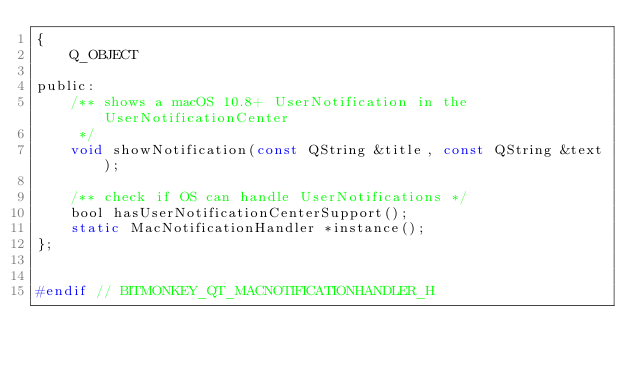<code> <loc_0><loc_0><loc_500><loc_500><_C_>{
    Q_OBJECT

public:
    /** shows a macOS 10.8+ UserNotification in the UserNotificationCenter
     */
    void showNotification(const QString &title, const QString &text);

    /** check if OS can handle UserNotifications */
    bool hasUserNotificationCenterSupport();
    static MacNotificationHandler *instance();
};


#endif // BITMONKEY_QT_MACNOTIFICATIONHANDLER_H
</code> 